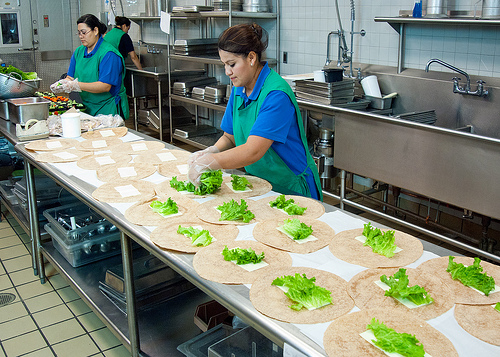Describe the tasks being performed in the background by the individuals. In the background, two individuals are actively engaged in prepping vegetables. One person is washing vegetables, likely lettuce, under a faucet, while another is chopping vegetables on a cutting board. 